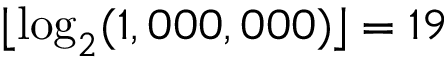Convert formula to latex. <formula><loc_0><loc_0><loc_500><loc_500>\lfloor \log _ { 2 } ( 1 , 0 0 0 , 0 0 0 ) \rfloor = 1 9</formula> 